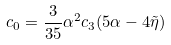Convert formula to latex. <formula><loc_0><loc_0><loc_500><loc_500>c _ { 0 } = \frac { 3 } { 3 5 } \alpha ^ { 2 } c _ { 3 } ( 5 \alpha - 4 \tilde { \eta } )</formula> 